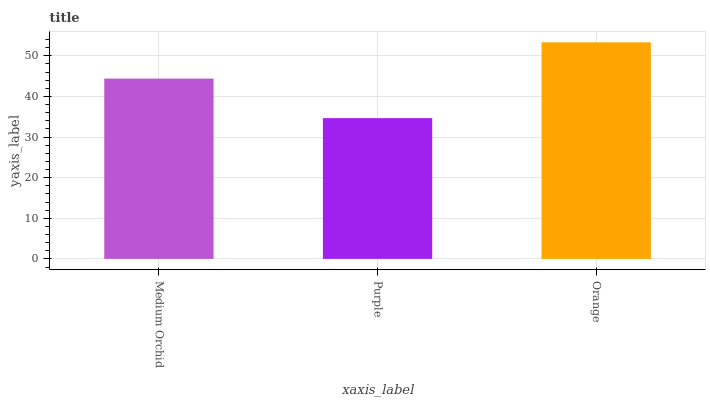Is Purple the minimum?
Answer yes or no. Yes. Is Orange the maximum?
Answer yes or no. Yes. Is Orange the minimum?
Answer yes or no. No. Is Purple the maximum?
Answer yes or no. No. Is Orange greater than Purple?
Answer yes or no. Yes. Is Purple less than Orange?
Answer yes or no. Yes. Is Purple greater than Orange?
Answer yes or no. No. Is Orange less than Purple?
Answer yes or no. No. Is Medium Orchid the high median?
Answer yes or no. Yes. Is Medium Orchid the low median?
Answer yes or no. Yes. Is Purple the high median?
Answer yes or no. No. Is Purple the low median?
Answer yes or no. No. 